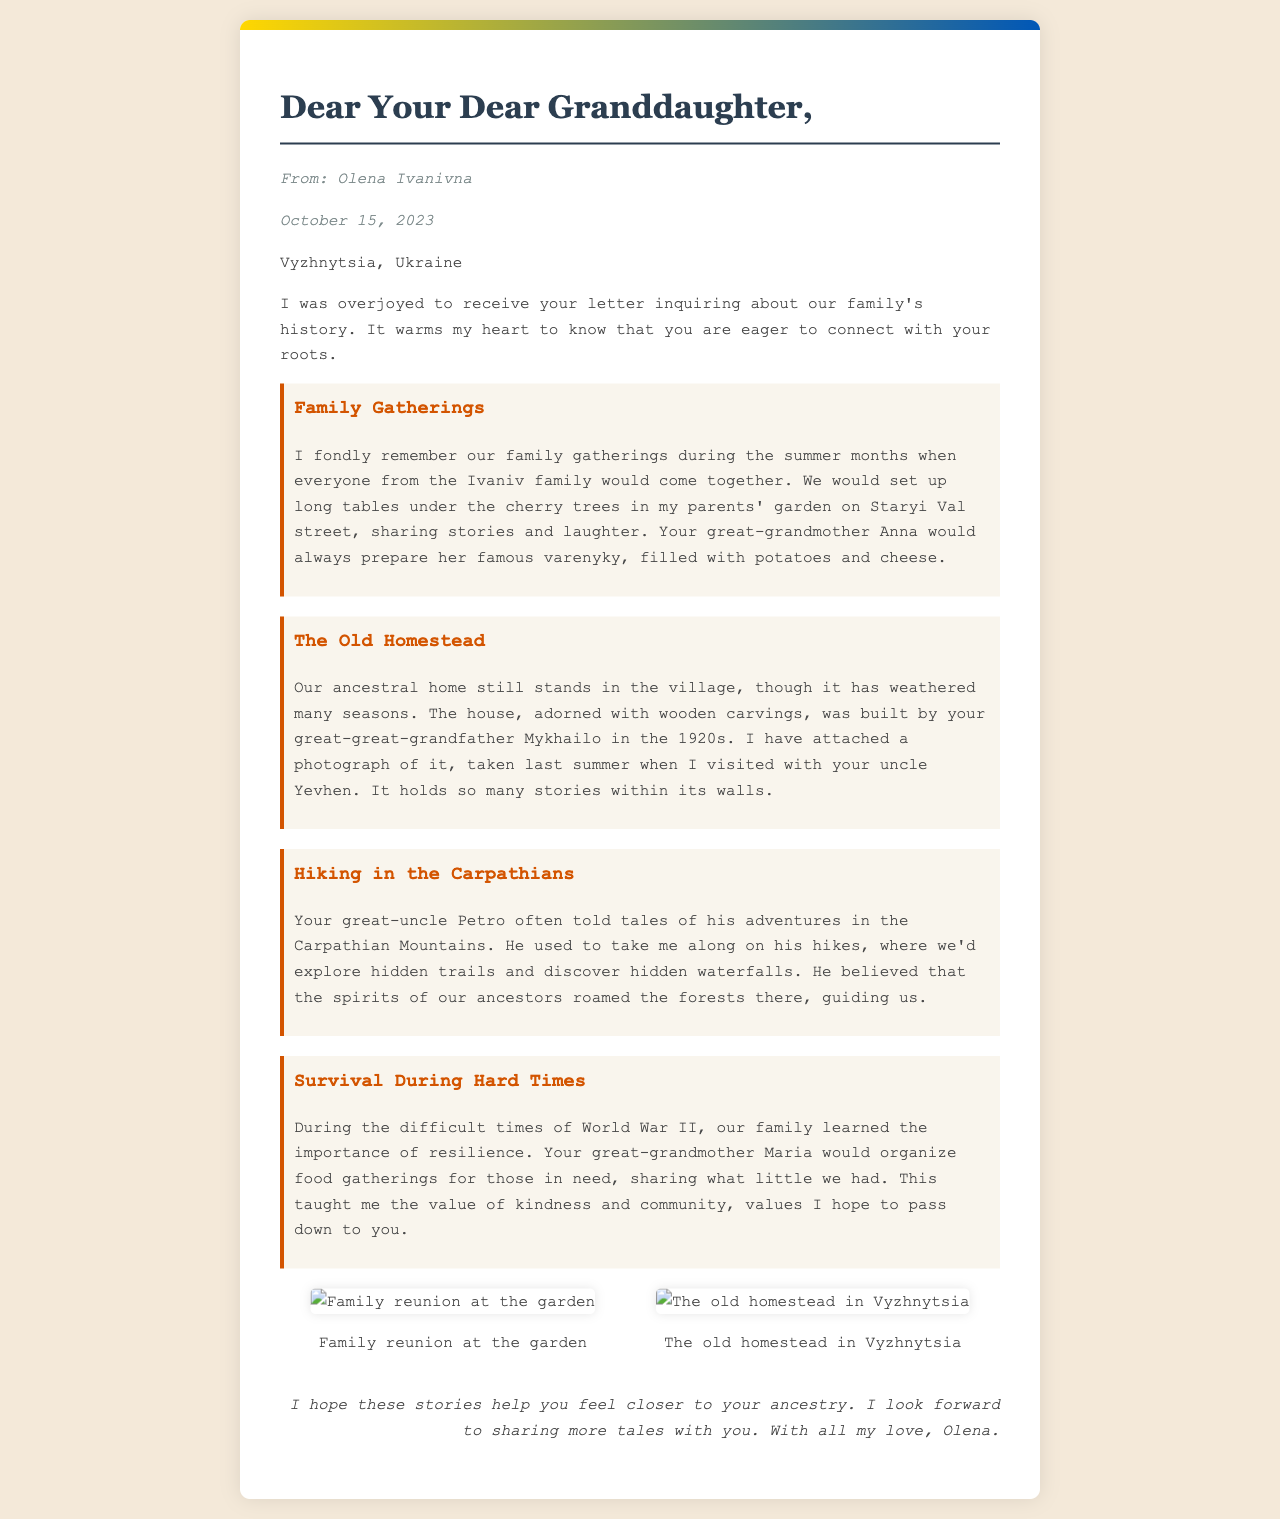What is the sender's name? The sender's name is mentioned in the letter's heading as Olena Ivanivna.
Answer: Olena Ivanivna What is the date of the letter? The date is specified in the document as October 15, 2023.
Answer: October 15, 2023 Where does the sender live? The sender's location is stated in the letter as Vyzhnytsia, Ukraine.
Answer: Vyzhnytsia, Ukraine What dish did the great-grandmother prepare during family gatherings? A specific dish is mentioned in the family gathering memory as varenyky, filled with potatoes and cheese.
Answer: Varenyky Who built the ancestral home? The letter states that the ancestral home was built by Mykhailo, the great-great-grandfather.
Answer: Mykhailo What did great-uncle Petro believe about the Carpathian Mountains? The document mentions that he believed the spirits of their ancestors roamed the forests there.
Answer: Spirits of ancestors What values did the great-grandmother teach during hard times? The document highlights the values of kindness and community that were emphasized during difficult times.
Answer: Kindness and community How many photographs are included in the letter? There are two photographs mentioned in the photography section of the document.
Answer: Two What is the main purpose of the letter? The letter’s main purpose is to share family history and stories from the sender to her granddaughter.
Answer: Share family history 